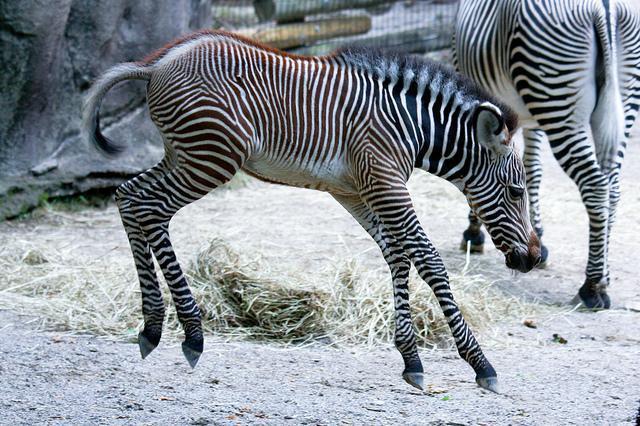How many zebras are visible?
Give a very brief answer. 2. 